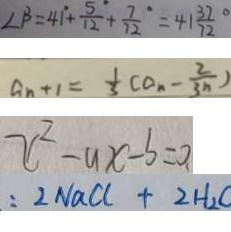Convert formula to latex. <formula><loc_0><loc_0><loc_500><loc_500>\angle \beta = 4 1 ^ { \circ } + \frac { 5 } { 1 2 } ^ { \circ } + \frac { 7 } { 7 2 } ^ { \circ } = 4 1 \frac { 3 7 } { 7 2 } ^ { \circ } 
 a _ { n + 1 } = \frac { 1 } { 3 } ( a _ { n } - \frac { 2 } { 3 n } ) 
 x ^ { 2 } - a x - b = 0 . 
 : 2 N a C l + 2 H _ { 2 }</formula> 